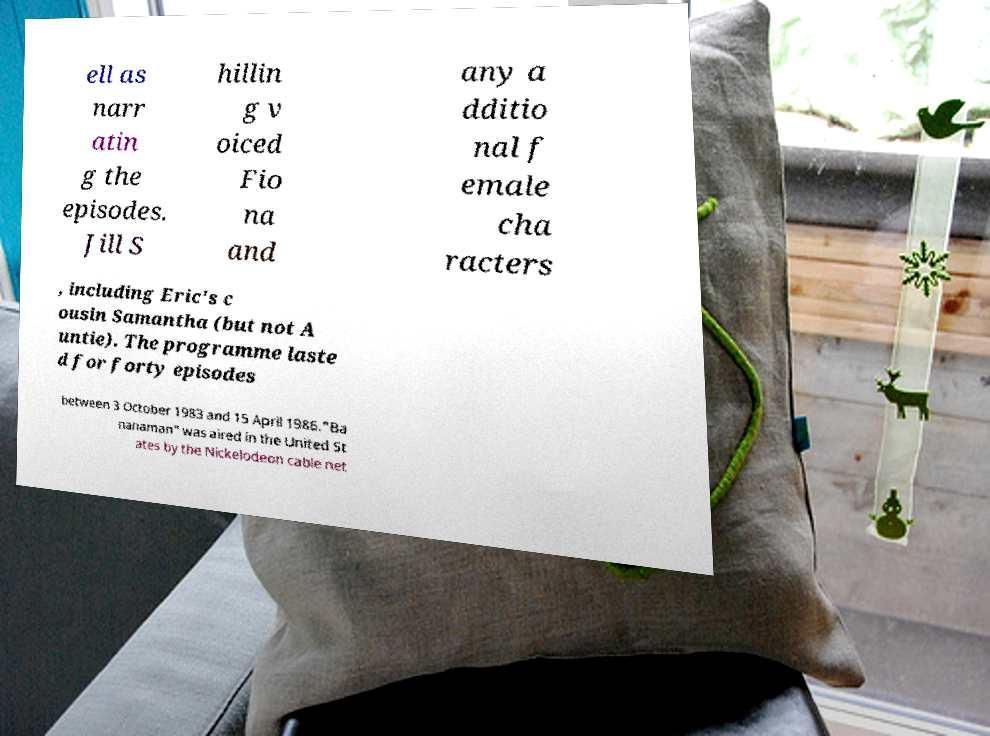Can you accurately transcribe the text from the provided image for me? ell as narr atin g the episodes. Jill S hillin g v oiced Fio na and any a dditio nal f emale cha racters , including Eric's c ousin Samantha (but not A untie). The programme laste d for forty episodes between 3 October 1983 and 15 April 1986."Ba nanaman" was aired in the United St ates by the Nickelodeon cable net 